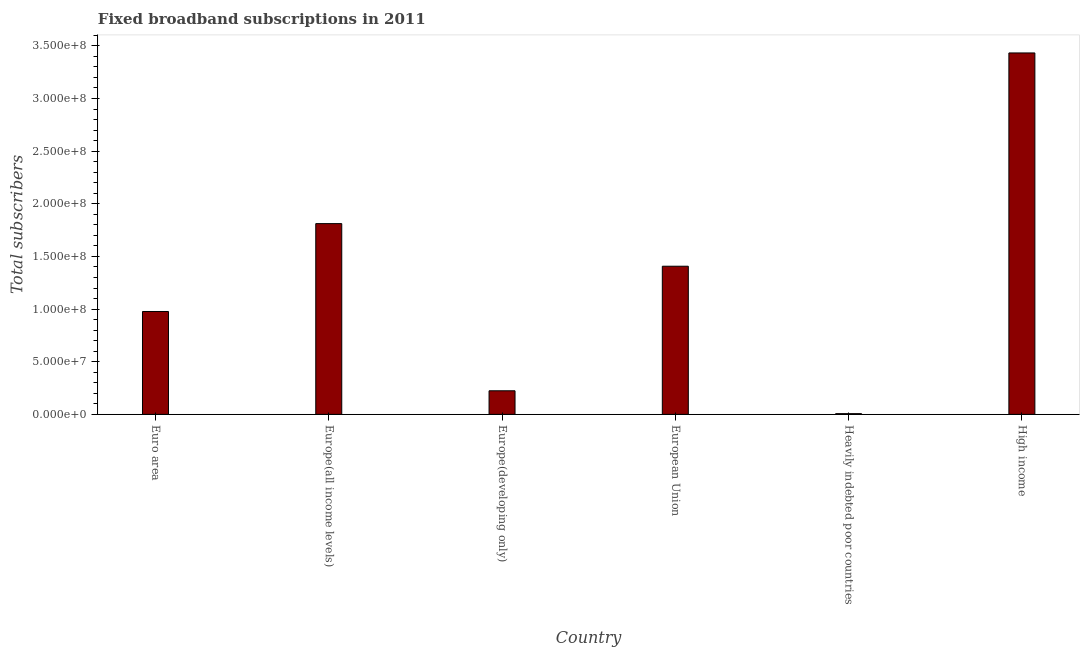Does the graph contain any zero values?
Offer a terse response. No. What is the title of the graph?
Your answer should be very brief. Fixed broadband subscriptions in 2011. What is the label or title of the X-axis?
Your response must be concise. Country. What is the label or title of the Y-axis?
Provide a succinct answer. Total subscribers. What is the total number of fixed broadband subscriptions in Europe(developing only)?
Provide a short and direct response. 2.24e+07. Across all countries, what is the maximum total number of fixed broadband subscriptions?
Make the answer very short. 3.43e+08. Across all countries, what is the minimum total number of fixed broadband subscriptions?
Provide a succinct answer. 6.72e+05. In which country was the total number of fixed broadband subscriptions minimum?
Your answer should be very brief. Heavily indebted poor countries. What is the sum of the total number of fixed broadband subscriptions?
Your response must be concise. 7.86e+08. What is the difference between the total number of fixed broadband subscriptions in Europe(developing only) and European Union?
Your answer should be compact. -1.18e+08. What is the average total number of fixed broadband subscriptions per country?
Provide a short and direct response. 1.31e+08. What is the median total number of fixed broadband subscriptions?
Your answer should be compact. 1.19e+08. What is the ratio of the total number of fixed broadband subscriptions in Europe(developing only) to that in European Union?
Make the answer very short. 0.16. What is the difference between the highest and the second highest total number of fixed broadband subscriptions?
Your answer should be compact. 1.62e+08. What is the difference between the highest and the lowest total number of fixed broadband subscriptions?
Offer a very short reply. 3.43e+08. In how many countries, is the total number of fixed broadband subscriptions greater than the average total number of fixed broadband subscriptions taken over all countries?
Give a very brief answer. 3. What is the difference between two consecutive major ticks on the Y-axis?
Make the answer very short. 5.00e+07. Are the values on the major ticks of Y-axis written in scientific E-notation?
Offer a terse response. Yes. What is the Total subscribers of Euro area?
Offer a very short reply. 9.77e+07. What is the Total subscribers in Europe(all income levels)?
Provide a succinct answer. 1.81e+08. What is the Total subscribers of Europe(developing only)?
Your answer should be very brief. 2.24e+07. What is the Total subscribers of European Union?
Your answer should be very brief. 1.41e+08. What is the Total subscribers in Heavily indebted poor countries?
Your answer should be compact. 6.72e+05. What is the Total subscribers of High income?
Provide a short and direct response. 3.43e+08. What is the difference between the Total subscribers in Euro area and Europe(all income levels)?
Offer a terse response. -8.35e+07. What is the difference between the Total subscribers in Euro area and Europe(developing only)?
Give a very brief answer. 7.53e+07. What is the difference between the Total subscribers in Euro area and European Union?
Provide a short and direct response. -4.30e+07. What is the difference between the Total subscribers in Euro area and Heavily indebted poor countries?
Ensure brevity in your answer.  9.70e+07. What is the difference between the Total subscribers in Euro area and High income?
Offer a terse response. -2.46e+08. What is the difference between the Total subscribers in Europe(all income levels) and Europe(developing only)?
Provide a short and direct response. 1.59e+08. What is the difference between the Total subscribers in Europe(all income levels) and European Union?
Make the answer very short. 4.05e+07. What is the difference between the Total subscribers in Europe(all income levels) and Heavily indebted poor countries?
Ensure brevity in your answer.  1.80e+08. What is the difference between the Total subscribers in Europe(all income levels) and High income?
Your response must be concise. -1.62e+08. What is the difference between the Total subscribers in Europe(developing only) and European Union?
Keep it short and to the point. -1.18e+08. What is the difference between the Total subscribers in Europe(developing only) and Heavily indebted poor countries?
Provide a succinct answer. 2.17e+07. What is the difference between the Total subscribers in Europe(developing only) and High income?
Your response must be concise. -3.21e+08. What is the difference between the Total subscribers in European Union and Heavily indebted poor countries?
Provide a short and direct response. 1.40e+08. What is the difference between the Total subscribers in European Union and High income?
Offer a very short reply. -2.03e+08. What is the difference between the Total subscribers in Heavily indebted poor countries and High income?
Keep it short and to the point. -3.43e+08. What is the ratio of the Total subscribers in Euro area to that in Europe(all income levels)?
Keep it short and to the point. 0.54. What is the ratio of the Total subscribers in Euro area to that in Europe(developing only)?
Offer a very short reply. 4.36. What is the ratio of the Total subscribers in Euro area to that in European Union?
Provide a short and direct response. 0.69. What is the ratio of the Total subscribers in Euro area to that in Heavily indebted poor countries?
Make the answer very short. 145.49. What is the ratio of the Total subscribers in Euro area to that in High income?
Offer a terse response. 0.28. What is the ratio of the Total subscribers in Europe(all income levels) to that in Europe(developing only)?
Your answer should be very brief. 8.09. What is the ratio of the Total subscribers in Europe(all income levels) to that in European Union?
Provide a succinct answer. 1.29. What is the ratio of the Total subscribers in Europe(all income levels) to that in Heavily indebted poor countries?
Your answer should be very brief. 269.76. What is the ratio of the Total subscribers in Europe(all income levels) to that in High income?
Your answer should be compact. 0.53. What is the ratio of the Total subscribers in Europe(developing only) to that in European Union?
Your response must be concise. 0.16. What is the ratio of the Total subscribers in Europe(developing only) to that in Heavily indebted poor countries?
Your response must be concise. 33.35. What is the ratio of the Total subscribers in Europe(developing only) to that in High income?
Offer a terse response. 0.07. What is the ratio of the Total subscribers in European Union to that in Heavily indebted poor countries?
Your answer should be compact. 209.49. What is the ratio of the Total subscribers in European Union to that in High income?
Provide a short and direct response. 0.41. What is the ratio of the Total subscribers in Heavily indebted poor countries to that in High income?
Keep it short and to the point. 0. 